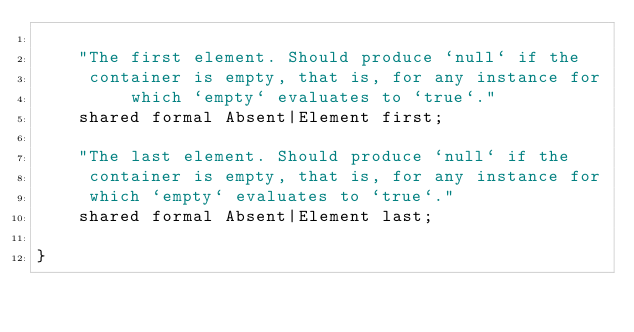Convert code to text. <code><loc_0><loc_0><loc_500><loc_500><_Ceylon_>    
    "The first element. Should produce `null` if the 
     container is empty, that is, for any instance for
         which `empty` evaluates to `true`."
    shared formal Absent|Element first;
    
    "The last element. Should produce `null` if the
     container is empty, that is, for any instance for
     which `empty` evaluates to `true`."
    shared formal Absent|Element last;    
    
}
</code> 